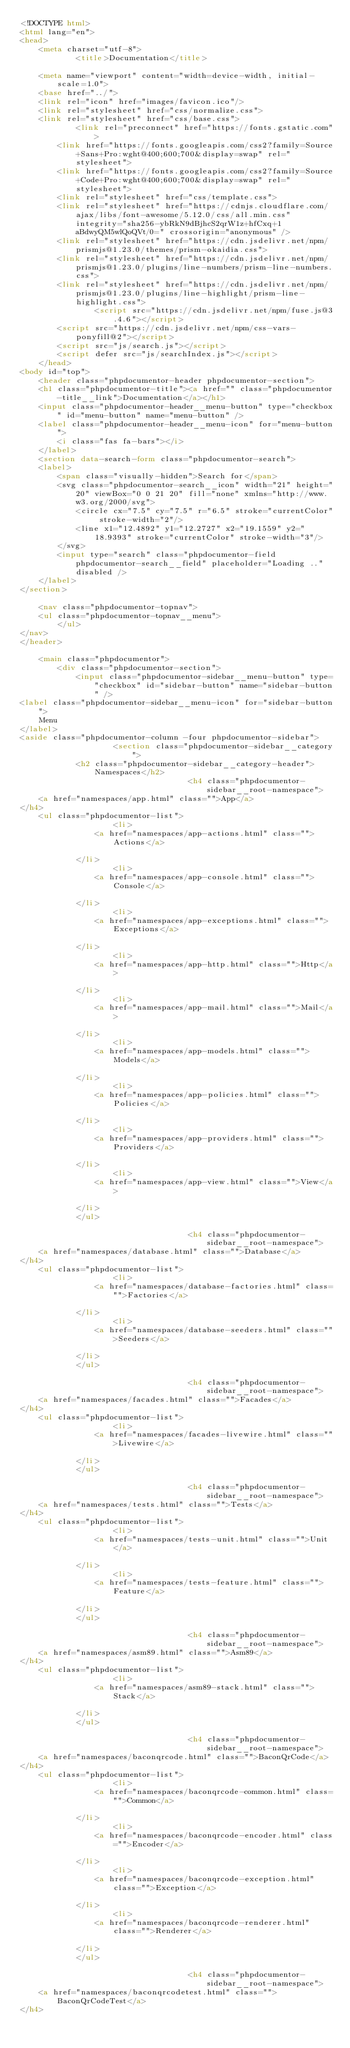Convert code to text. <code><loc_0><loc_0><loc_500><loc_500><_HTML_><!DOCTYPE html>
<html lang="en">
<head>
    <meta charset="utf-8">
            <title>Documentation</title>
    
    <meta name="viewport" content="width=device-width, initial-scale=1.0">
    <base href="../">
    <link rel="icon" href="images/favicon.ico"/>
    <link rel="stylesheet" href="css/normalize.css">
    <link rel="stylesheet" href="css/base.css">
            <link rel="preconnect" href="https://fonts.gstatic.com">
        <link href="https://fonts.googleapis.com/css2?family=Source+Sans+Pro:wght@400;600;700&display=swap" rel="stylesheet">
        <link href="https://fonts.googleapis.com/css2?family=Source+Code+Pro:wght@400;600;700&display=swap" rel="stylesheet">
        <link rel="stylesheet" href="css/template.css">
        <link rel="stylesheet" href="https://cdnjs.cloudflare.com/ajax/libs/font-awesome/5.12.0/css/all.min.css" integrity="sha256-ybRkN9dBjhcS2qrW1z+hfCxq+1aBdwyQM5wlQoQVt/0=" crossorigin="anonymous" />
        <link rel="stylesheet" href="https://cdn.jsdelivr.net/npm/prismjs@1.23.0/themes/prism-okaidia.css">
        <link rel="stylesheet" href="https://cdn.jsdelivr.net/npm/prismjs@1.23.0/plugins/line-numbers/prism-line-numbers.css">
        <link rel="stylesheet" href="https://cdn.jsdelivr.net/npm/prismjs@1.23.0/plugins/line-highlight/prism-line-highlight.css">
                <script src="https://cdn.jsdelivr.net/npm/fuse.js@3.4.6"></script>
        <script src="https://cdn.jsdelivr.net/npm/css-vars-ponyfill@2"></script>
        <script src="js/search.js"></script>
        <script defer src="js/searchIndex.js"></script>
    </head>
<body id="top">
    <header class="phpdocumentor-header phpdocumentor-section">
    <h1 class="phpdocumentor-title"><a href="" class="phpdocumentor-title__link">Documentation</a></h1>
    <input class="phpdocumentor-header__menu-button" type="checkbox" id="menu-button" name="menu-button" />
    <label class="phpdocumentor-header__menu-icon" for="menu-button">
        <i class="fas fa-bars"></i>
    </label>
    <section data-search-form class="phpdocumentor-search">
    <label>
        <span class="visually-hidden">Search for</span>
        <svg class="phpdocumentor-search__icon" width="21" height="20" viewBox="0 0 21 20" fill="none" xmlns="http://www.w3.org/2000/svg">
            <circle cx="7.5" cy="7.5" r="6.5" stroke="currentColor" stroke-width="2"/>
            <line x1="12.4892" y1="12.2727" x2="19.1559" y2="18.9393" stroke="currentColor" stroke-width="3"/>
        </svg>
        <input type="search" class="phpdocumentor-field phpdocumentor-search__field" placeholder="Loading .." disabled />
    </label>
</section>

    <nav class="phpdocumentor-topnav">
    <ul class="phpdocumentor-topnav__menu">
        </ul>
</nav>
</header>

    <main class="phpdocumentor">
        <div class="phpdocumentor-section">
            <input class="phpdocumentor-sidebar__menu-button" type="checkbox" id="sidebar-button" name="sidebar-button" />
<label class="phpdocumentor-sidebar__menu-icon" for="sidebar-button">
    Menu
</label>
<aside class="phpdocumentor-column -four phpdocumentor-sidebar">
                    <section class="phpdocumentor-sidebar__category">
            <h2 class="phpdocumentor-sidebar__category-header">Namespaces</h2>
                                    <h4 class="phpdocumentor-sidebar__root-namespace">
    <a href="namespaces/app.html" class="">App</a>
</h4>
    <ul class="phpdocumentor-list">
                    <li>
                <a href="namespaces/app-actions.html" class="">Actions</a>
                
            </li>
                    <li>
                <a href="namespaces/app-console.html" class="">Console</a>
                
            </li>
                    <li>
                <a href="namespaces/app-exceptions.html" class="">Exceptions</a>
                
            </li>
                    <li>
                <a href="namespaces/app-http.html" class="">Http</a>
                
            </li>
                    <li>
                <a href="namespaces/app-mail.html" class="">Mail</a>
                
            </li>
                    <li>
                <a href="namespaces/app-models.html" class="">Models</a>
                
            </li>
                    <li>
                <a href="namespaces/app-policies.html" class="">Policies</a>
                
            </li>
                    <li>
                <a href="namespaces/app-providers.html" class="">Providers</a>
                
            </li>
                    <li>
                <a href="namespaces/app-view.html" class="">View</a>
                
            </li>
            </ul>

                                    <h4 class="phpdocumentor-sidebar__root-namespace">
    <a href="namespaces/database.html" class="">Database</a>
</h4>
    <ul class="phpdocumentor-list">
                    <li>
                <a href="namespaces/database-factories.html" class="">Factories</a>
                
            </li>
                    <li>
                <a href="namespaces/database-seeders.html" class="">Seeders</a>
                
            </li>
            </ul>

                                    <h4 class="phpdocumentor-sidebar__root-namespace">
    <a href="namespaces/facades.html" class="">Facades</a>
</h4>
    <ul class="phpdocumentor-list">
                    <li>
                <a href="namespaces/facades-livewire.html" class="">Livewire</a>
                
            </li>
            </ul>

                                    <h4 class="phpdocumentor-sidebar__root-namespace">
    <a href="namespaces/tests.html" class="">Tests</a>
</h4>
    <ul class="phpdocumentor-list">
                    <li>
                <a href="namespaces/tests-unit.html" class="">Unit</a>
                
            </li>
                    <li>
                <a href="namespaces/tests-feature.html" class="">Feature</a>
                
            </li>
            </ul>

                                    <h4 class="phpdocumentor-sidebar__root-namespace">
    <a href="namespaces/asm89.html" class="">Asm89</a>
</h4>
    <ul class="phpdocumentor-list">
                    <li>
                <a href="namespaces/asm89-stack.html" class="">Stack</a>
                
            </li>
            </ul>

                                    <h4 class="phpdocumentor-sidebar__root-namespace">
    <a href="namespaces/baconqrcode.html" class="">BaconQrCode</a>
</h4>
    <ul class="phpdocumentor-list">
                    <li>
                <a href="namespaces/baconqrcode-common.html" class="">Common</a>
                
            </li>
                    <li>
                <a href="namespaces/baconqrcode-encoder.html" class="">Encoder</a>
                
            </li>
                    <li>
                <a href="namespaces/baconqrcode-exception.html" class="">Exception</a>
                
            </li>
                    <li>
                <a href="namespaces/baconqrcode-renderer.html" class="">Renderer</a>
                
            </li>
            </ul>

                                    <h4 class="phpdocumentor-sidebar__root-namespace">
    <a href="namespaces/baconqrcodetest.html" class="">BaconQrCodeTest</a>
</h4></code> 